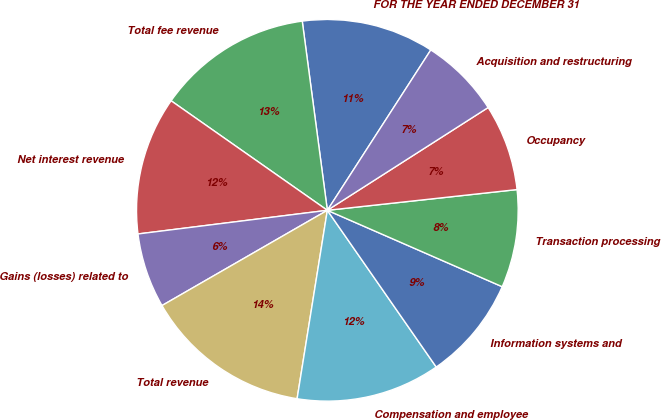<chart> <loc_0><loc_0><loc_500><loc_500><pie_chart><fcel>FOR THE YEAR ENDED DECEMBER 31<fcel>Total fee revenue<fcel>Net interest revenue<fcel>Gains (losses) related to<fcel>Total revenue<fcel>Compensation and employee<fcel>Information systems and<fcel>Transaction processing<fcel>Occupancy<fcel>Acquisition and restructuring<nl><fcel>11.22%<fcel>13.17%<fcel>11.71%<fcel>6.34%<fcel>14.15%<fcel>12.2%<fcel>8.78%<fcel>8.29%<fcel>7.32%<fcel>6.83%<nl></chart> 